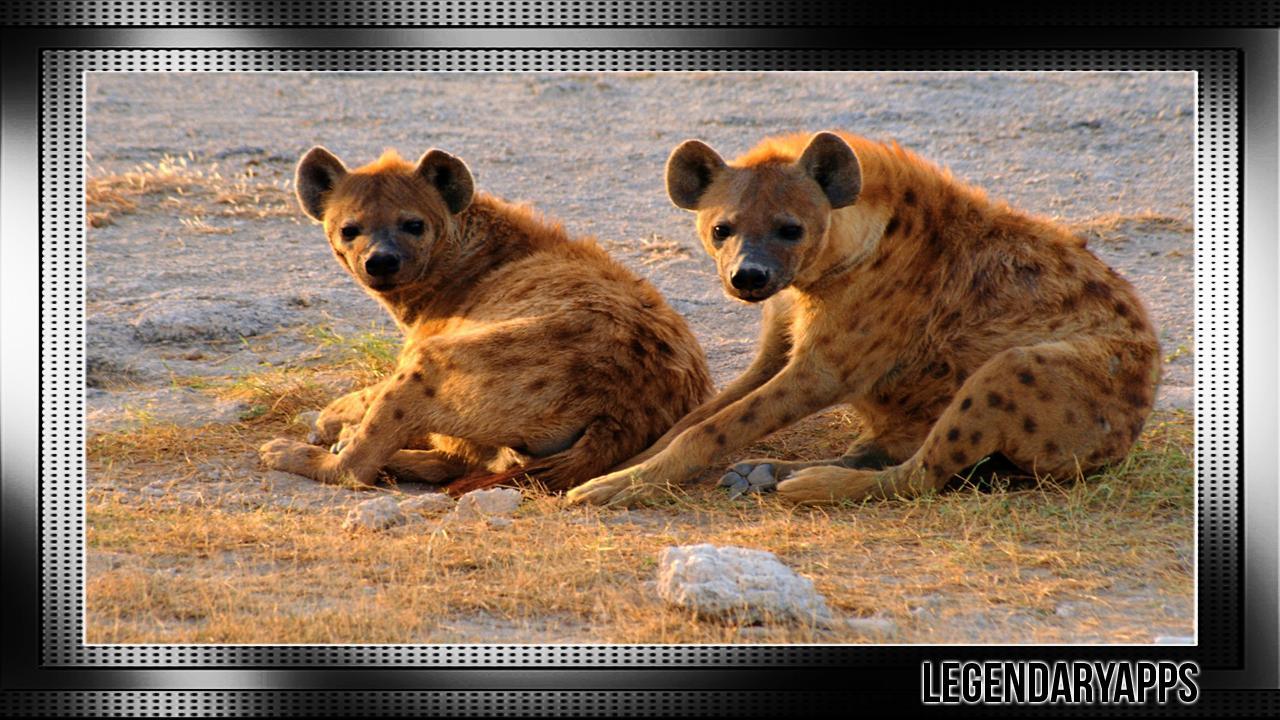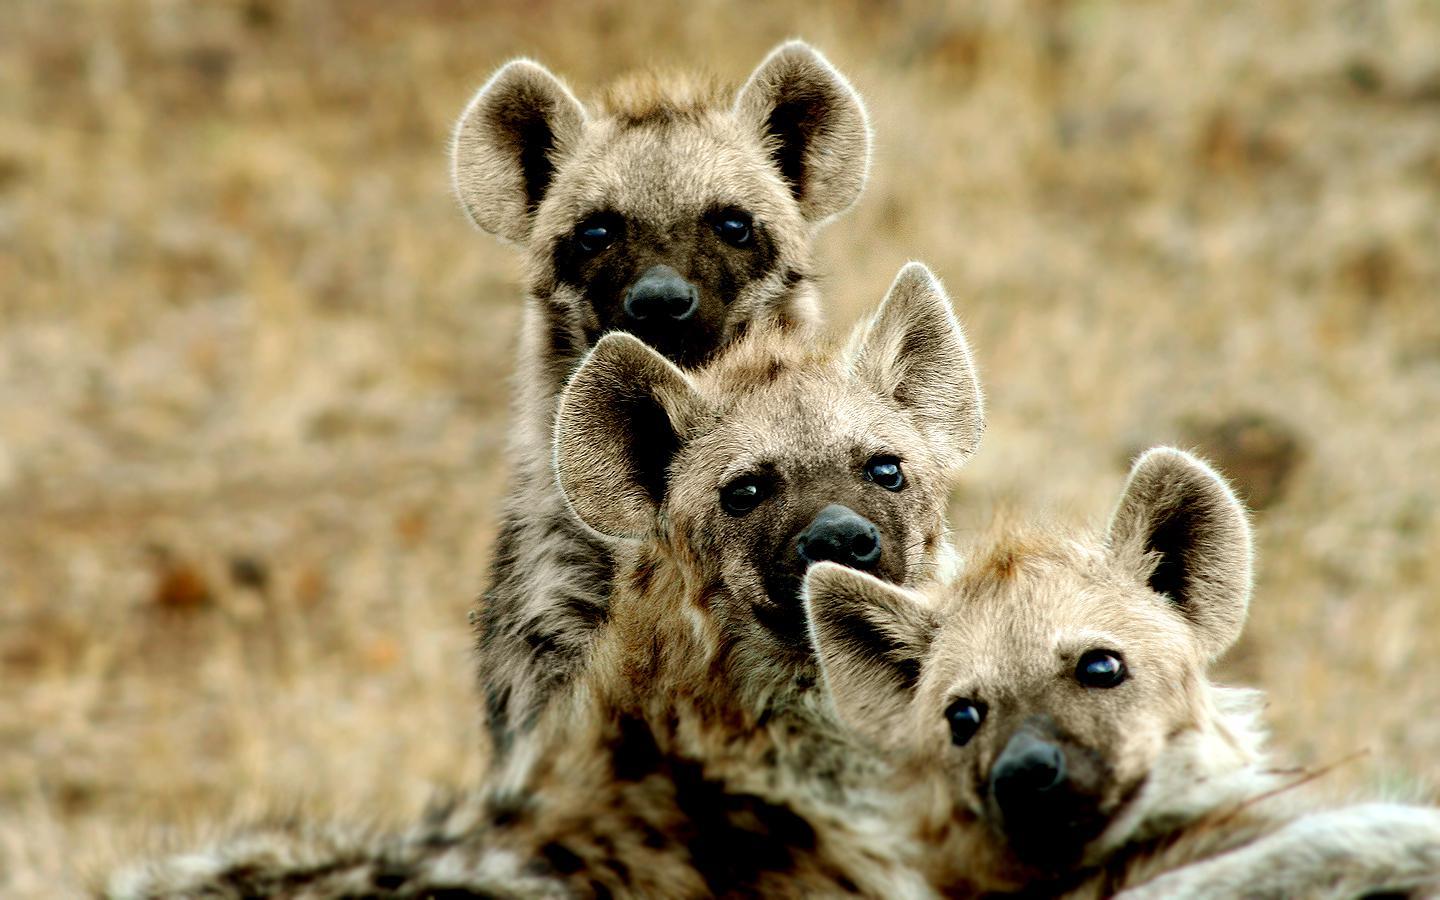The first image is the image on the left, the second image is the image on the right. Given the left and right images, does the statement "A hyena has its mouth wide open with sharp teeth visible." hold true? Answer yes or no. No. The first image is the image on the left, the second image is the image on the right. Evaluate the accuracy of this statement regarding the images: "One image shows a hyena baring its fangs in a wide-opened mouth.". Is it true? Answer yes or no. No. 